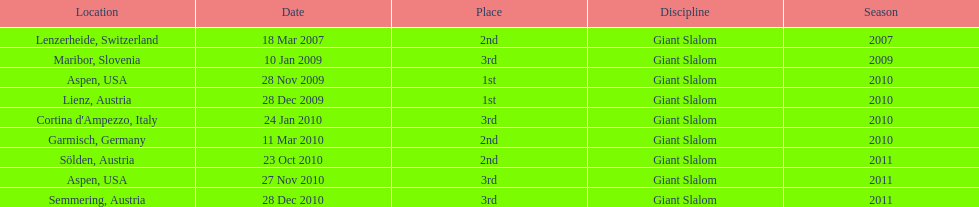The final race finishing place was not 1st but what other place? 3rd. 